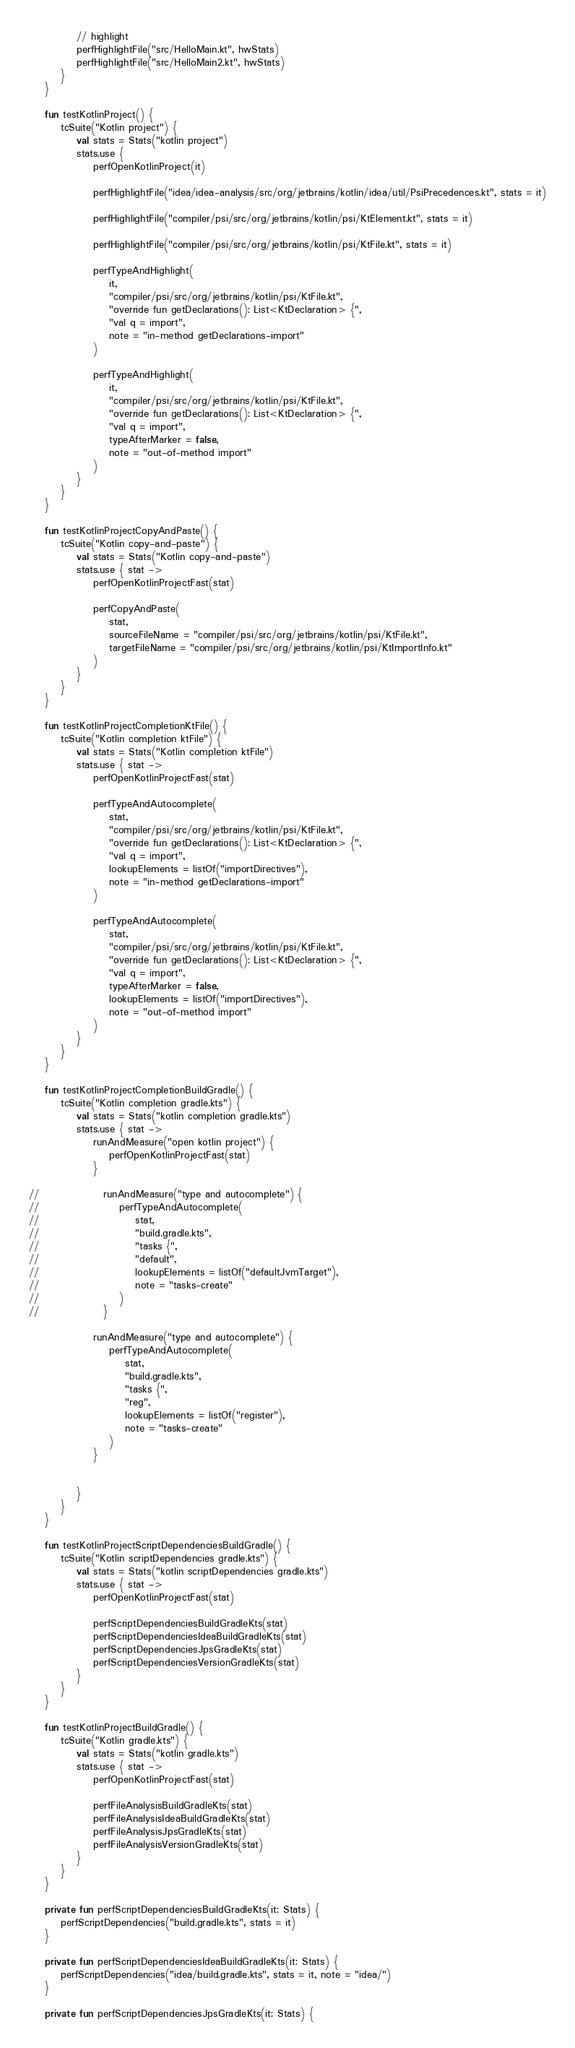Convert code to text. <code><loc_0><loc_0><loc_500><loc_500><_Kotlin_>            // highlight
            perfHighlightFile("src/HelloMain.kt", hwStats)
            perfHighlightFile("src/HelloMain2.kt", hwStats)
        }
    }

    fun testKotlinProject() {
        tcSuite("Kotlin project") {
            val stats = Stats("kotlin project")
            stats.use {
                perfOpenKotlinProject(it)

                perfHighlightFile("idea/idea-analysis/src/org/jetbrains/kotlin/idea/util/PsiPrecedences.kt", stats = it)

                perfHighlightFile("compiler/psi/src/org/jetbrains/kotlin/psi/KtElement.kt", stats = it)

                perfHighlightFile("compiler/psi/src/org/jetbrains/kotlin/psi/KtFile.kt", stats = it)

                perfTypeAndHighlight(
                    it,
                    "compiler/psi/src/org/jetbrains/kotlin/psi/KtFile.kt",
                    "override fun getDeclarations(): List<KtDeclaration> {",
                    "val q = import",
                    note = "in-method getDeclarations-import"
                )

                perfTypeAndHighlight(
                    it,
                    "compiler/psi/src/org/jetbrains/kotlin/psi/KtFile.kt",
                    "override fun getDeclarations(): List<KtDeclaration> {",
                    "val q = import",
                    typeAfterMarker = false,
                    note = "out-of-method import"
                )
            }
        }
    }

    fun testKotlinProjectCopyAndPaste() {
        tcSuite("Kotlin copy-and-paste") {
            val stats = Stats("Kotlin copy-and-paste")
            stats.use { stat ->
                perfOpenKotlinProjectFast(stat)

                perfCopyAndPaste(
                    stat,
                    sourceFileName = "compiler/psi/src/org/jetbrains/kotlin/psi/KtFile.kt",
                    targetFileName = "compiler/psi/src/org/jetbrains/kotlin/psi/KtImportInfo.kt"
                )
            }
        }
    }

    fun testKotlinProjectCompletionKtFile() {
        tcSuite("Kotlin completion ktFile") {
            val stats = Stats("Kotlin completion ktFile")
            stats.use { stat ->
                perfOpenKotlinProjectFast(stat)

                perfTypeAndAutocomplete(
                    stat,
                    "compiler/psi/src/org/jetbrains/kotlin/psi/KtFile.kt",
                    "override fun getDeclarations(): List<KtDeclaration> {",
                    "val q = import",
                    lookupElements = listOf("importDirectives"),
                    note = "in-method getDeclarations-import"
                )

                perfTypeAndAutocomplete(
                    stat,
                    "compiler/psi/src/org/jetbrains/kotlin/psi/KtFile.kt",
                    "override fun getDeclarations(): List<KtDeclaration> {",
                    "val q = import",
                    typeAfterMarker = false,
                    lookupElements = listOf("importDirectives"),
                    note = "out-of-method import"
                )
            }
        }
    }

    fun testKotlinProjectCompletionBuildGradle() {
        tcSuite("Kotlin completion gradle.kts") {
            val stats = Stats("kotlin completion gradle.kts")
            stats.use { stat ->
                runAndMeasure("open kotlin project") {
                    perfOpenKotlinProjectFast(stat)
                }

//                runAndMeasure("type and autocomplete") {
//                    perfTypeAndAutocomplete(
//                        stat,
//                        "build.gradle.kts",
//                        "tasks {",
//                        "default",
//                        lookupElements = listOf("defaultJvmTarget"),
//                        note = "tasks-create"
//                    )
//                }

                runAndMeasure("type and autocomplete") {
                    perfTypeAndAutocomplete(
                        stat,
                        "build.gradle.kts",
                        "tasks {",
                        "reg",
                        lookupElements = listOf("register"),
                        note = "tasks-create"
                    )
                }


            }
        }
    }

    fun testKotlinProjectScriptDependenciesBuildGradle() {
        tcSuite("Kotlin scriptDependencies gradle.kts") {
            val stats = Stats("kotlin scriptDependencies gradle.kts")
            stats.use { stat ->
                perfOpenKotlinProjectFast(stat)

                perfScriptDependenciesBuildGradleKts(stat)
                perfScriptDependenciesIdeaBuildGradleKts(stat)
                perfScriptDependenciesJpsGradleKts(stat)
                perfScriptDependenciesVersionGradleKts(stat)
            }
        }
    }

    fun testKotlinProjectBuildGradle() {
        tcSuite("Kotlin gradle.kts") {
            val stats = Stats("kotlin gradle.kts")
            stats.use { stat ->
                perfOpenKotlinProjectFast(stat)

                perfFileAnalysisBuildGradleKts(stat)
                perfFileAnalysisIdeaBuildGradleKts(stat)
                perfFileAnalysisJpsGradleKts(stat)
                perfFileAnalysisVersionGradleKts(stat)
            }
        }
    }

    private fun perfScriptDependenciesBuildGradleKts(it: Stats) {
        perfScriptDependencies("build.gradle.kts", stats = it)
    }

    private fun perfScriptDependenciesIdeaBuildGradleKts(it: Stats) {
        perfScriptDependencies("idea/build.gradle.kts", stats = it, note = "idea/")
    }

    private fun perfScriptDependenciesJpsGradleKts(it: Stats) {</code> 